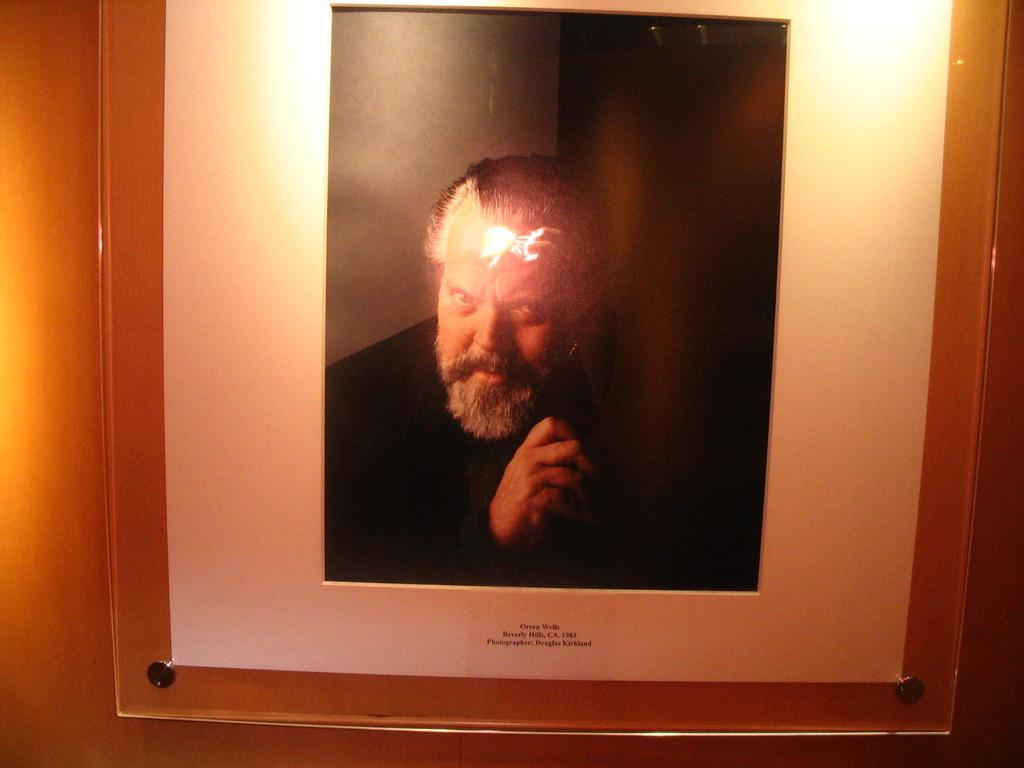What object is present in the image that holds a photo? There is a glass photo frame in the image. What is displayed inside the photo frame? The photo frame contains a person's photo. Is there any text associated with the photo frame? Yes, there is text at the bottom of the photo frame. How is the photo frame positioned in the image? The photo frame is attached to a wall. How many oranges are used to measure the dimensions of the photo frame? There are no oranges present in the image, and they are not used to measure the dimensions of the photo frame. 